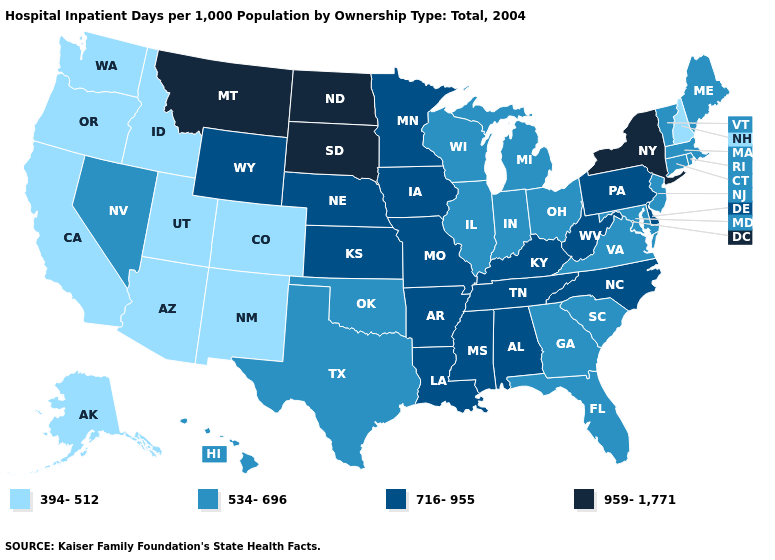Name the states that have a value in the range 716-955?
Concise answer only. Alabama, Arkansas, Delaware, Iowa, Kansas, Kentucky, Louisiana, Minnesota, Mississippi, Missouri, Nebraska, North Carolina, Pennsylvania, Tennessee, West Virginia, Wyoming. What is the value of North Carolina?
Short answer required. 716-955. What is the value of Montana?
Quick response, please. 959-1,771. What is the value of North Dakota?
Be succinct. 959-1,771. Does California have the lowest value in the USA?
Keep it brief. Yes. Does the first symbol in the legend represent the smallest category?
Quick response, please. Yes. Name the states that have a value in the range 534-696?
Short answer required. Connecticut, Florida, Georgia, Hawaii, Illinois, Indiana, Maine, Maryland, Massachusetts, Michigan, Nevada, New Jersey, Ohio, Oklahoma, Rhode Island, South Carolina, Texas, Vermont, Virginia, Wisconsin. Which states have the lowest value in the USA?
Be succinct. Alaska, Arizona, California, Colorado, Idaho, New Hampshire, New Mexico, Oregon, Utah, Washington. What is the highest value in states that border Arkansas?
Keep it brief. 716-955. Among the states that border Delaware , which have the lowest value?
Short answer required. Maryland, New Jersey. Does Texas have the highest value in the South?
Write a very short answer. No. Name the states that have a value in the range 394-512?
Short answer required. Alaska, Arizona, California, Colorado, Idaho, New Hampshire, New Mexico, Oregon, Utah, Washington. Name the states that have a value in the range 394-512?
Short answer required. Alaska, Arizona, California, Colorado, Idaho, New Hampshire, New Mexico, Oregon, Utah, Washington. Name the states that have a value in the range 959-1,771?
Write a very short answer. Montana, New York, North Dakota, South Dakota. Which states hav the highest value in the Northeast?
Be succinct. New York. 